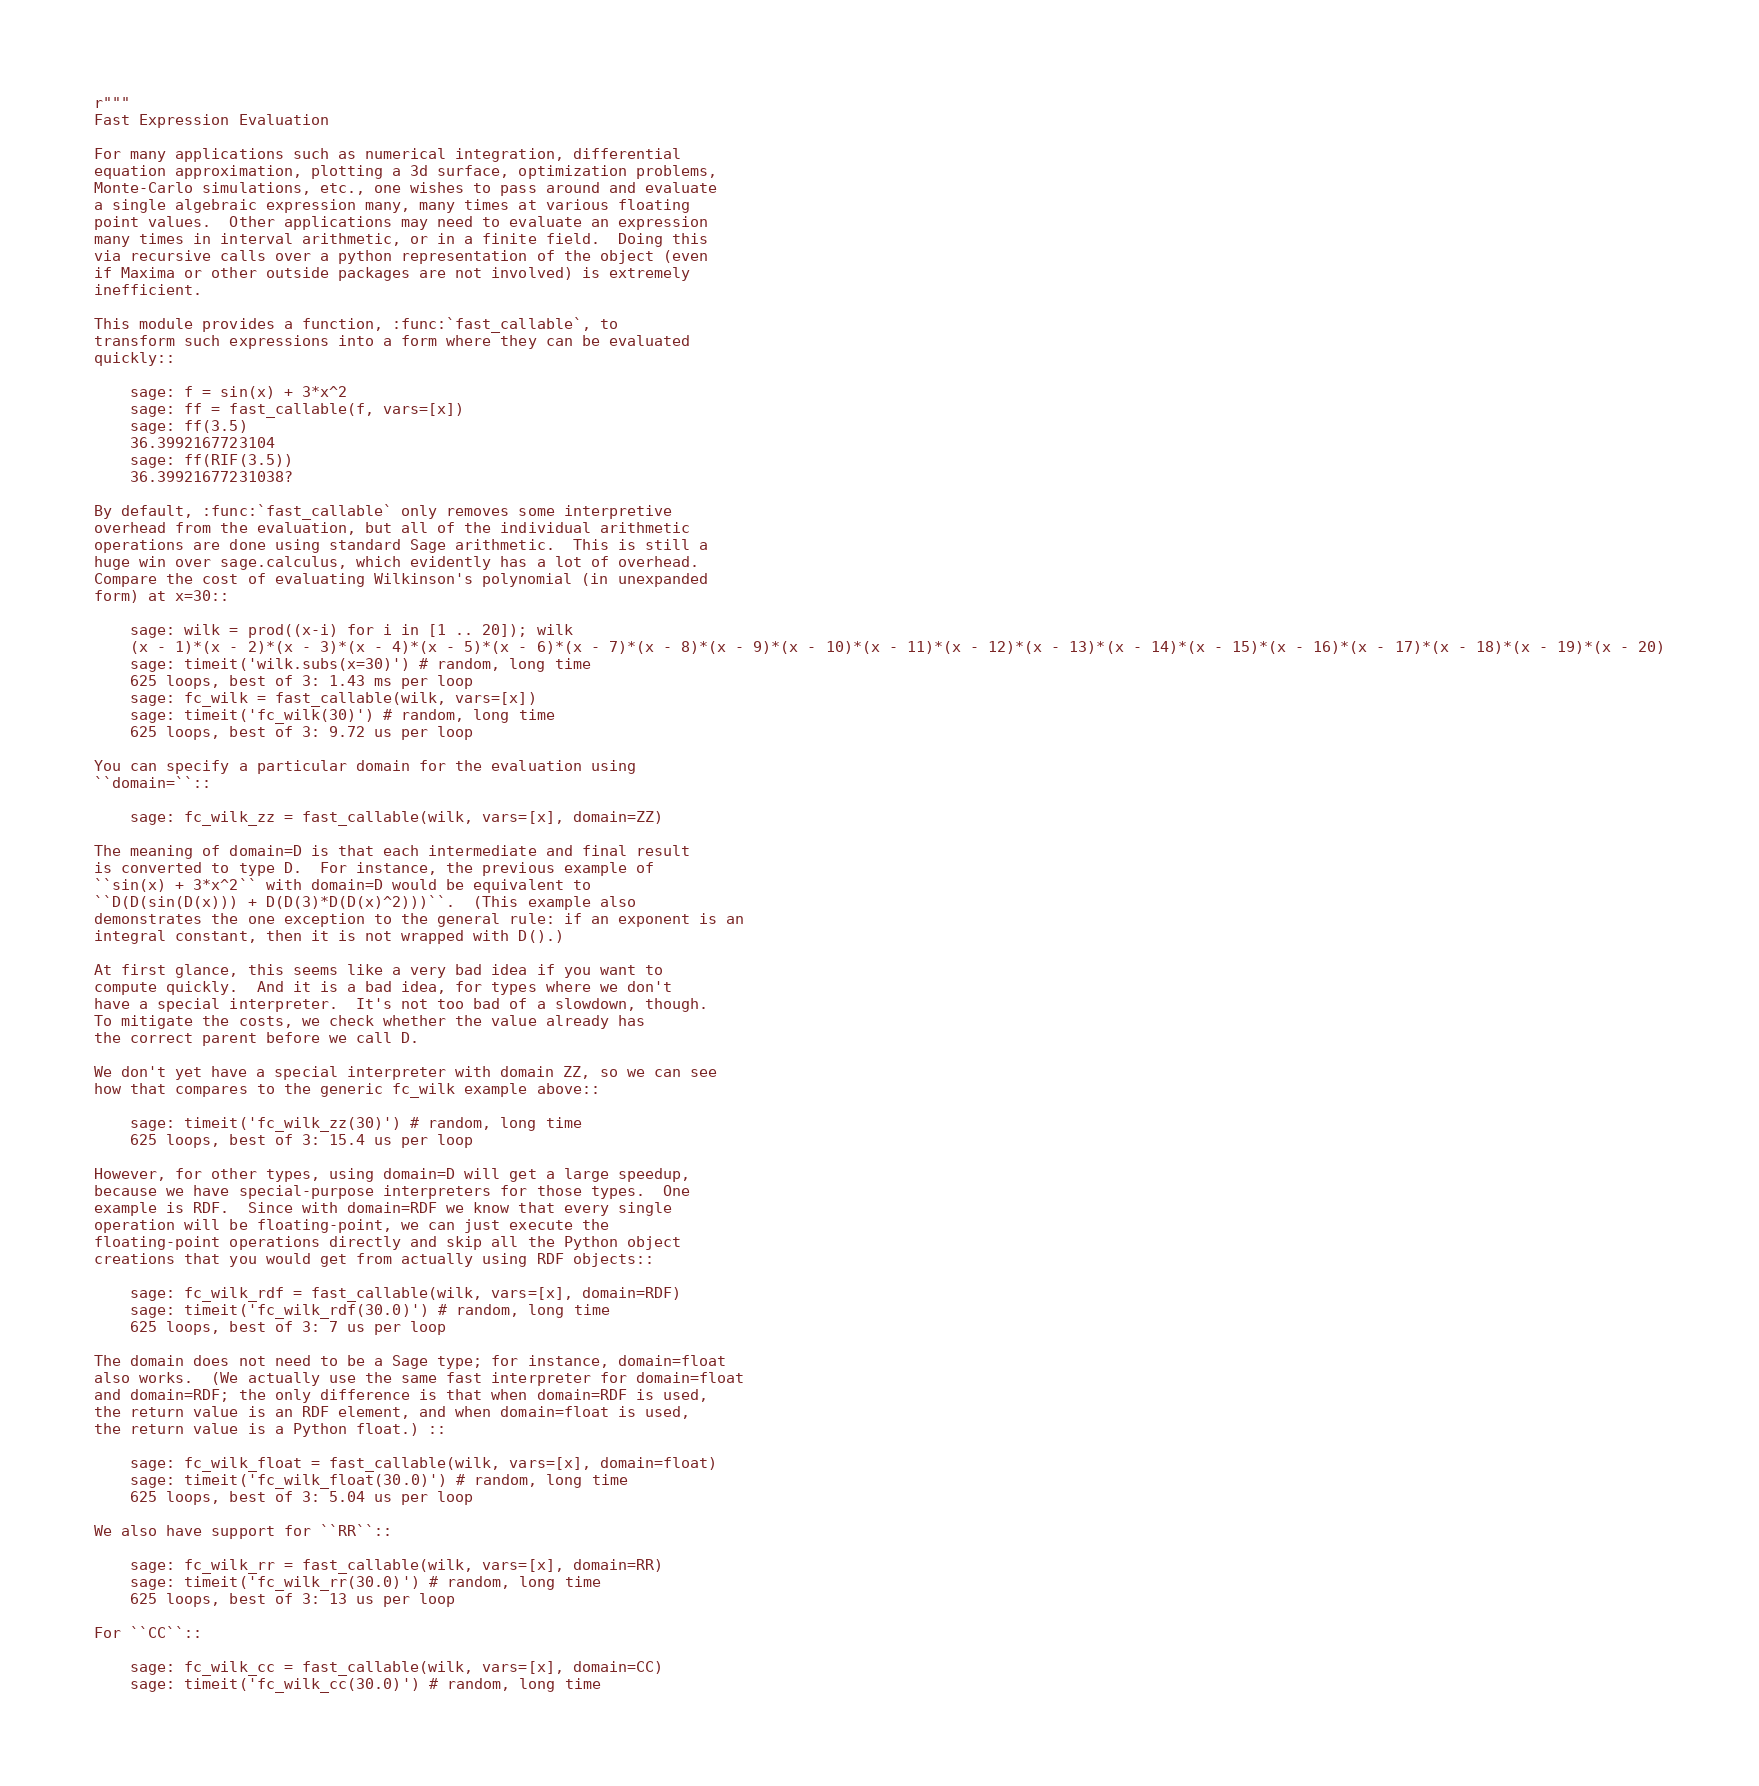Convert code to text. <code><loc_0><loc_0><loc_500><loc_500><_Cython_>r"""
Fast Expression Evaluation

For many applications such as numerical integration, differential
equation approximation, plotting a 3d surface, optimization problems,
Monte-Carlo simulations, etc., one wishes to pass around and evaluate
a single algebraic expression many, many times at various floating
point values.  Other applications may need to evaluate an expression
many times in interval arithmetic, or in a finite field.  Doing this
via recursive calls over a python representation of the object (even
if Maxima or other outside packages are not involved) is extremely
inefficient.

This module provides a function, :func:`fast_callable`, to
transform such expressions into a form where they can be evaluated
quickly::

    sage: f = sin(x) + 3*x^2
    sage: ff = fast_callable(f, vars=[x])
    sage: ff(3.5)
    36.3992167723104
    sage: ff(RIF(3.5))
    36.39921677231038?

By default, :func:`fast_callable` only removes some interpretive
overhead from the evaluation, but all of the individual arithmetic
operations are done using standard Sage arithmetic.  This is still a
huge win over sage.calculus, which evidently has a lot of overhead.
Compare the cost of evaluating Wilkinson's polynomial (in unexpanded
form) at x=30::

    sage: wilk = prod((x-i) for i in [1 .. 20]); wilk
    (x - 1)*(x - 2)*(x - 3)*(x - 4)*(x - 5)*(x - 6)*(x - 7)*(x - 8)*(x - 9)*(x - 10)*(x - 11)*(x - 12)*(x - 13)*(x - 14)*(x - 15)*(x - 16)*(x - 17)*(x - 18)*(x - 19)*(x - 20)
    sage: timeit('wilk.subs(x=30)') # random, long time
    625 loops, best of 3: 1.43 ms per loop
    sage: fc_wilk = fast_callable(wilk, vars=[x])
    sage: timeit('fc_wilk(30)') # random, long time
    625 loops, best of 3: 9.72 us per loop

You can specify a particular domain for the evaluation using
``domain=``::

    sage: fc_wilk_zz = fast_callable(wilk, vars=[x], domain=ZZ)

The meaning of domain=D is that each intermediate and final result
is converted to type D.  For instance, the previous example of
``sin(x) + 3*x^2`` with domain=D would be equivalent to
``D(D(sin(D(x))) + D(D(3)*D(D(x)^2)))``.  (This example also
demonstrates the one exception to the general rule: if an exponent is an
integral constant, then it is not wrapped with D().)

At first glance, this seems like a very bad idea if you want to
compute quickly.  And it is a bad idea, for types where we don't
have a special interpreter.  It's not too bad of a slowdown, though.
To mitigate the costs, we check whether the value already has
the correct parent before we call D.

We don't yet have a special interpreter with domain ZZ, so we can see
how that compares to the generic fc_wilk example above::

    sage: timeit('fc_wilk_zz(30)') # random, long time
    625 loops, best of 3: 15.4 us per loop

However, for other types, using domain=D will get a large speedup,
because we have special-purpose interpreters for those types.  One
example is RDF.  Since with domain=RDF we know that every single
operation will be floating-point, we can just execute the
floating-point operations directly and skip all the Python object
creations that you would get from actually using RDF objects::

    sage: fc_wilk_rdf = fast_callable(wilk, vars=[x], domain=RDF)
    sage: timeit('fc_wilk_rdf(30.0)') # random, long time
    625 loops, best of 3: 7 us per loop

The domain does not need to be a Sage type; for instance, domain=float
also works.  (We actually use the same fast interpreter for domain=float
and domain=RDF; the only difference is that when domain=RDF is used,
the return value is an RDF element, and when domain=float is used,
the return value is a Python float.) ::

    sage: fc_wilk_float = fast_callable(wilk, vars=[x], domain=float)
    sage: timeit('fc_wilk_float(30.0)') # random, long time
    625 loops, best of 3: 5.04 us per loop

We also have support for ``RR``::

    sage: fc_wilk_rr = fast_callable(wilk, vars=[x], domain=RR)
    sage: timeit('fc_wilk_rr(30.0)') # random, long time
    625 loops, best of 3: 13 us per loop

For ``CC``::

    sage: fc_wilk_cc = fast_callable(wilk, vars=[x], domain=CC)
    sage: timeit('fc_wilk_cc(30.0)') # random, long time</code> 